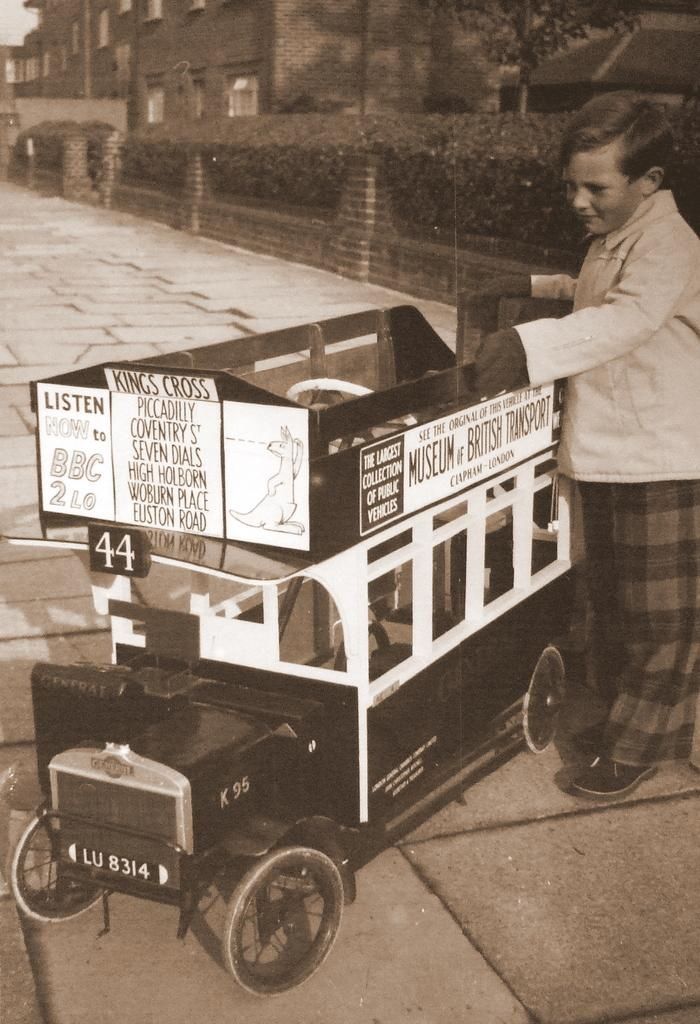What is the main subject of the image? The main subject of the image is a boy. What is the boy doing in the image? The boy is standing in the image. What is the boy holding in the image? The boy is holding a vehicle in the image. What can be seen in the background of the image? In the background of the image, there is a wall, plants, and buildings. What type of battle is taking place in the image? There is no battle present in the image; it features a boy standing and holding a vehicle. What part of the vehicle is the boy holding in the image? The provided facts do not specify which part of the vehicle the boy is holding. 